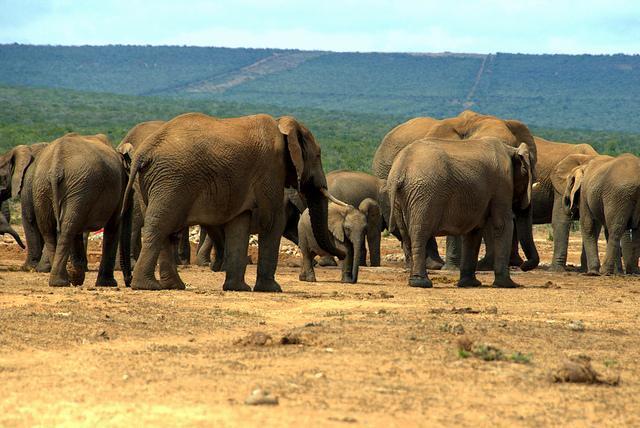How many elephants are there?
Give a very brief answer. 9. 